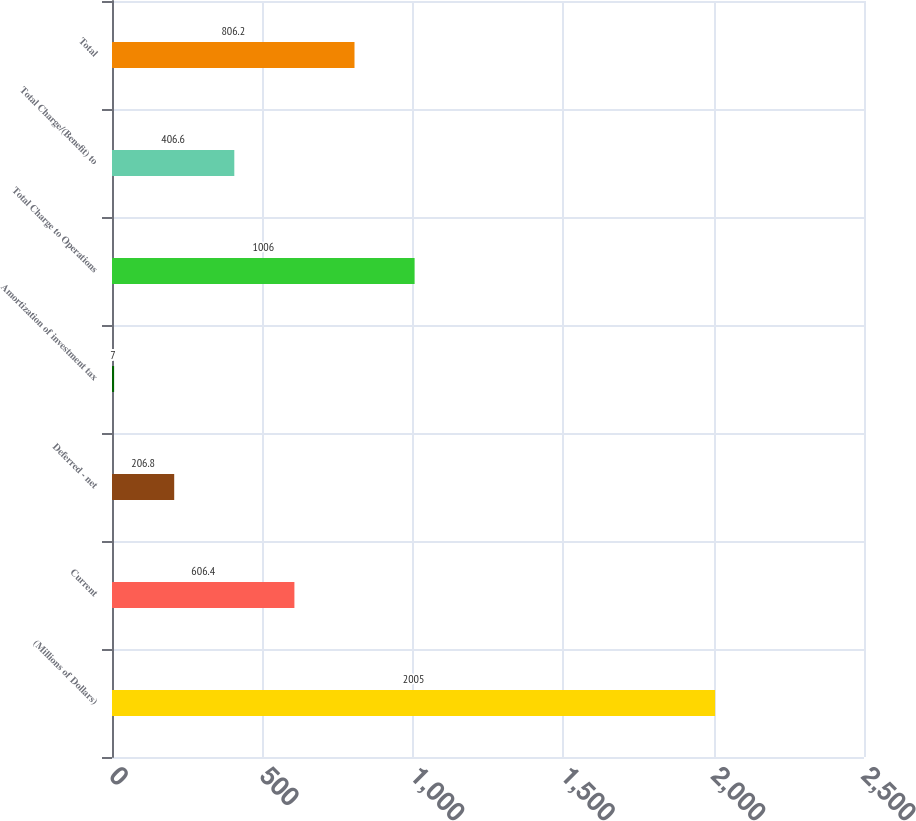Convert chart to OTSL. <chart><loc_0><loc_0><loc_500><loc_500><bar_chart><fcel>(Millions of Dollars)<fcel>Current<fcel>Deferred - net<fcel>Amortization of investment tax<fcel>Total Charge to Operations<fcel>Total Charge/(Benefit) to<fcel>Total<nl><fcel>2005<fcel>606.4<fcel>206.8<fcel>7<fcel>1006<fcel>406.6<fcel>806.2<nl></chart> 